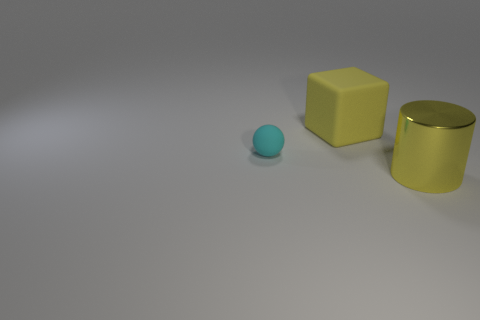Add 1 matte cylinders. How many objects exist? 4 Subtract all spheres. How many objects are left? 2 Add 3 spheres. How many spheres are left? 4 Add 1 cyan rubber spheres. How many cyan rubber spheres exist? 2 Subtract 1 cyan balls. How many objects are left? 2 Subtract all small brown matte cubes. Subtract all yellow things. How many objects are left? 1 